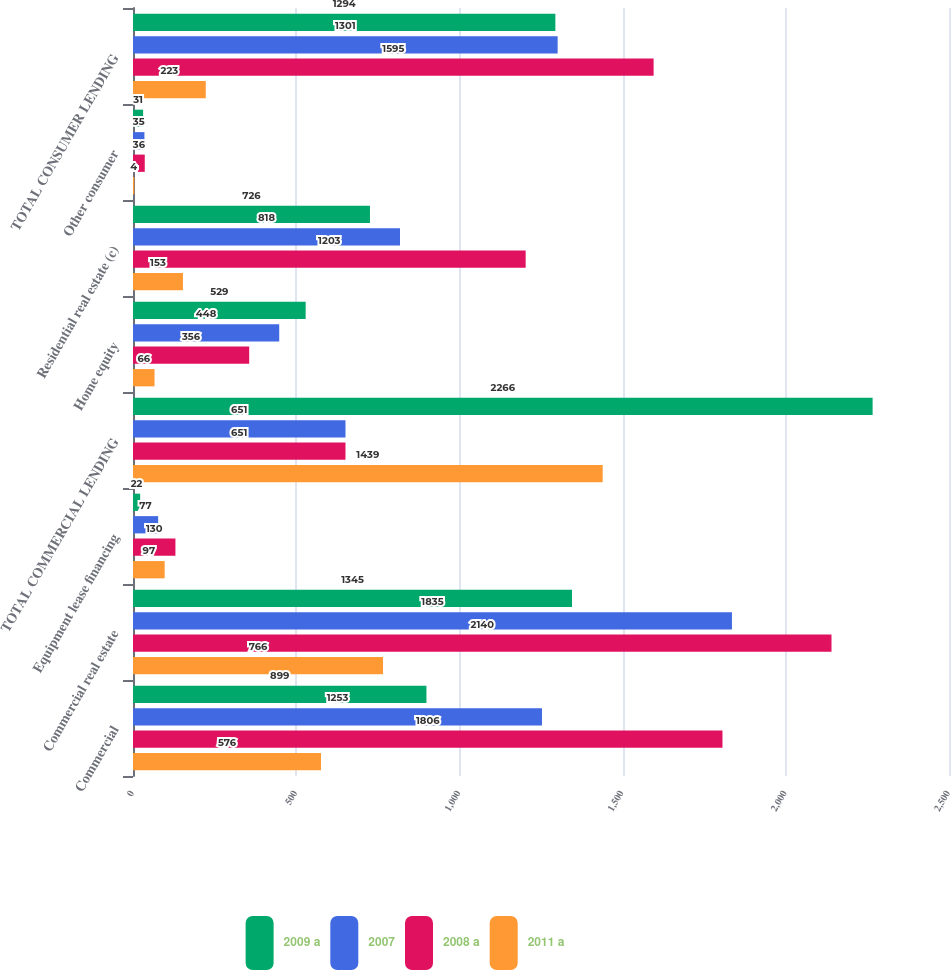Convert chart to OTSL. <chart><loc_0><loc_0><loc_500><loc_500><stacked_bar_chart><ecel><fcel>Commercial<fcel>Commercial real estate<fcel>Equipment lease financing<fcel>TOTAL COMMERCIAL LENDING<fcel>Home equity<fcel>Residential real estate (c)<fcel>Other consumer<fcel>TOTAL CONSUMER LENDING<nl><fcel>2009 a<fcel>899<fcel>1345<fcel>22<fcel>2266<fcel>529<fcel>726<fcel>31<fcel>1294<nl><fcel>2007<fcel>1253<fcel>1835<fcel>77<fcel>651<fcel>448<fcel>818<fcel>35<fcel>1301<nl><fcel>2008 a<fcel>1806<fcel>2140<fcel>130<fcel>651<fcel>356<fcel>1203<fcel>36<fcel>1595<nl><fcel>2011 a<fcel>576<fcel>766<fcel>97<fcel>1439<fcel>66<fcel>153<fcel>4<fcel>223<nl></chart> 